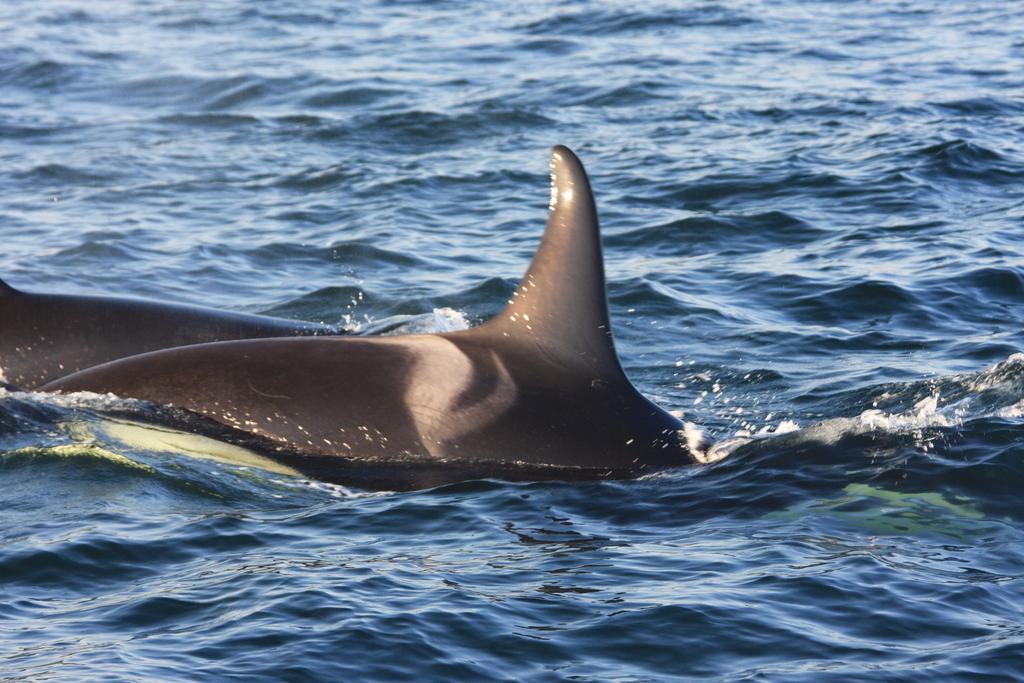Could you give a brief overview of what you see in this image? In this image I can see fish in the water, the fish is in gray color and the water is in blue color. 